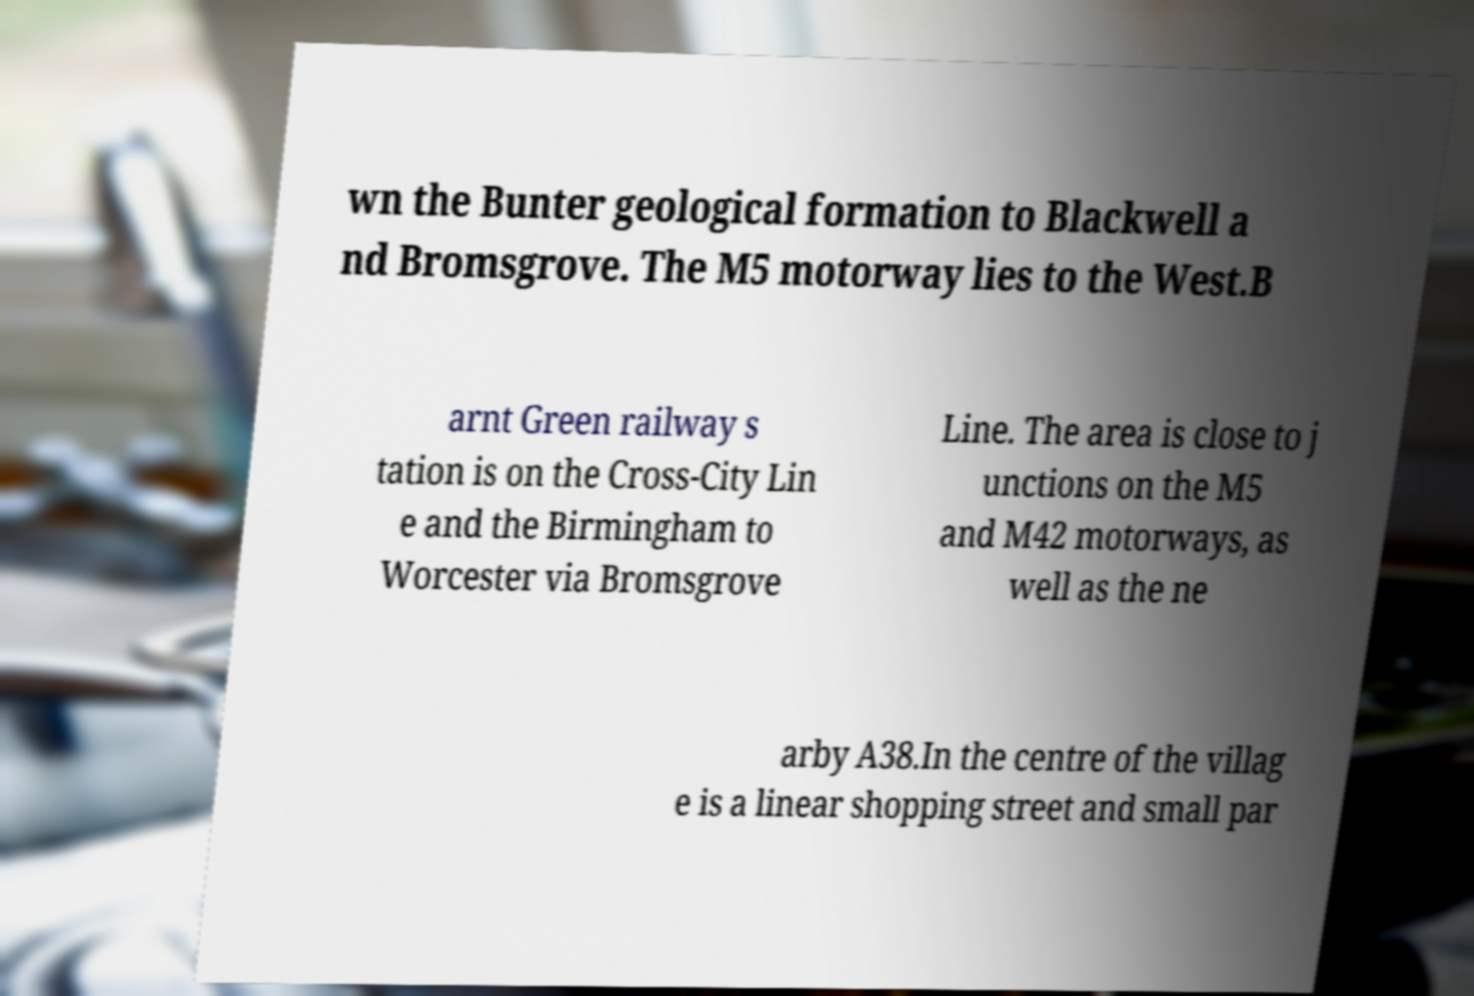Please identify and transcribe the text found in this image. wn the Bunter geological formation to Blackwell a nd Bromsgrove. The M5 motorway lies to the West.B arnt Green railway s tation is on the Cross-City Lin e and the Birmingham to Worcester via Bromsgrove Line. The area is close to j unctions on the M5 and M42 motorways, as well as the ne arby A38.In the centre of the villag e is a linear shopping street and small par 